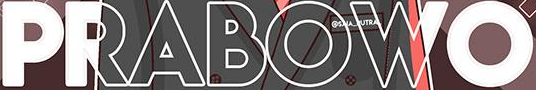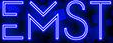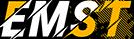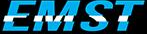Read the text content from these images in order, separated by a semicolon. PRABOWO; EMST; EMST; EMST 